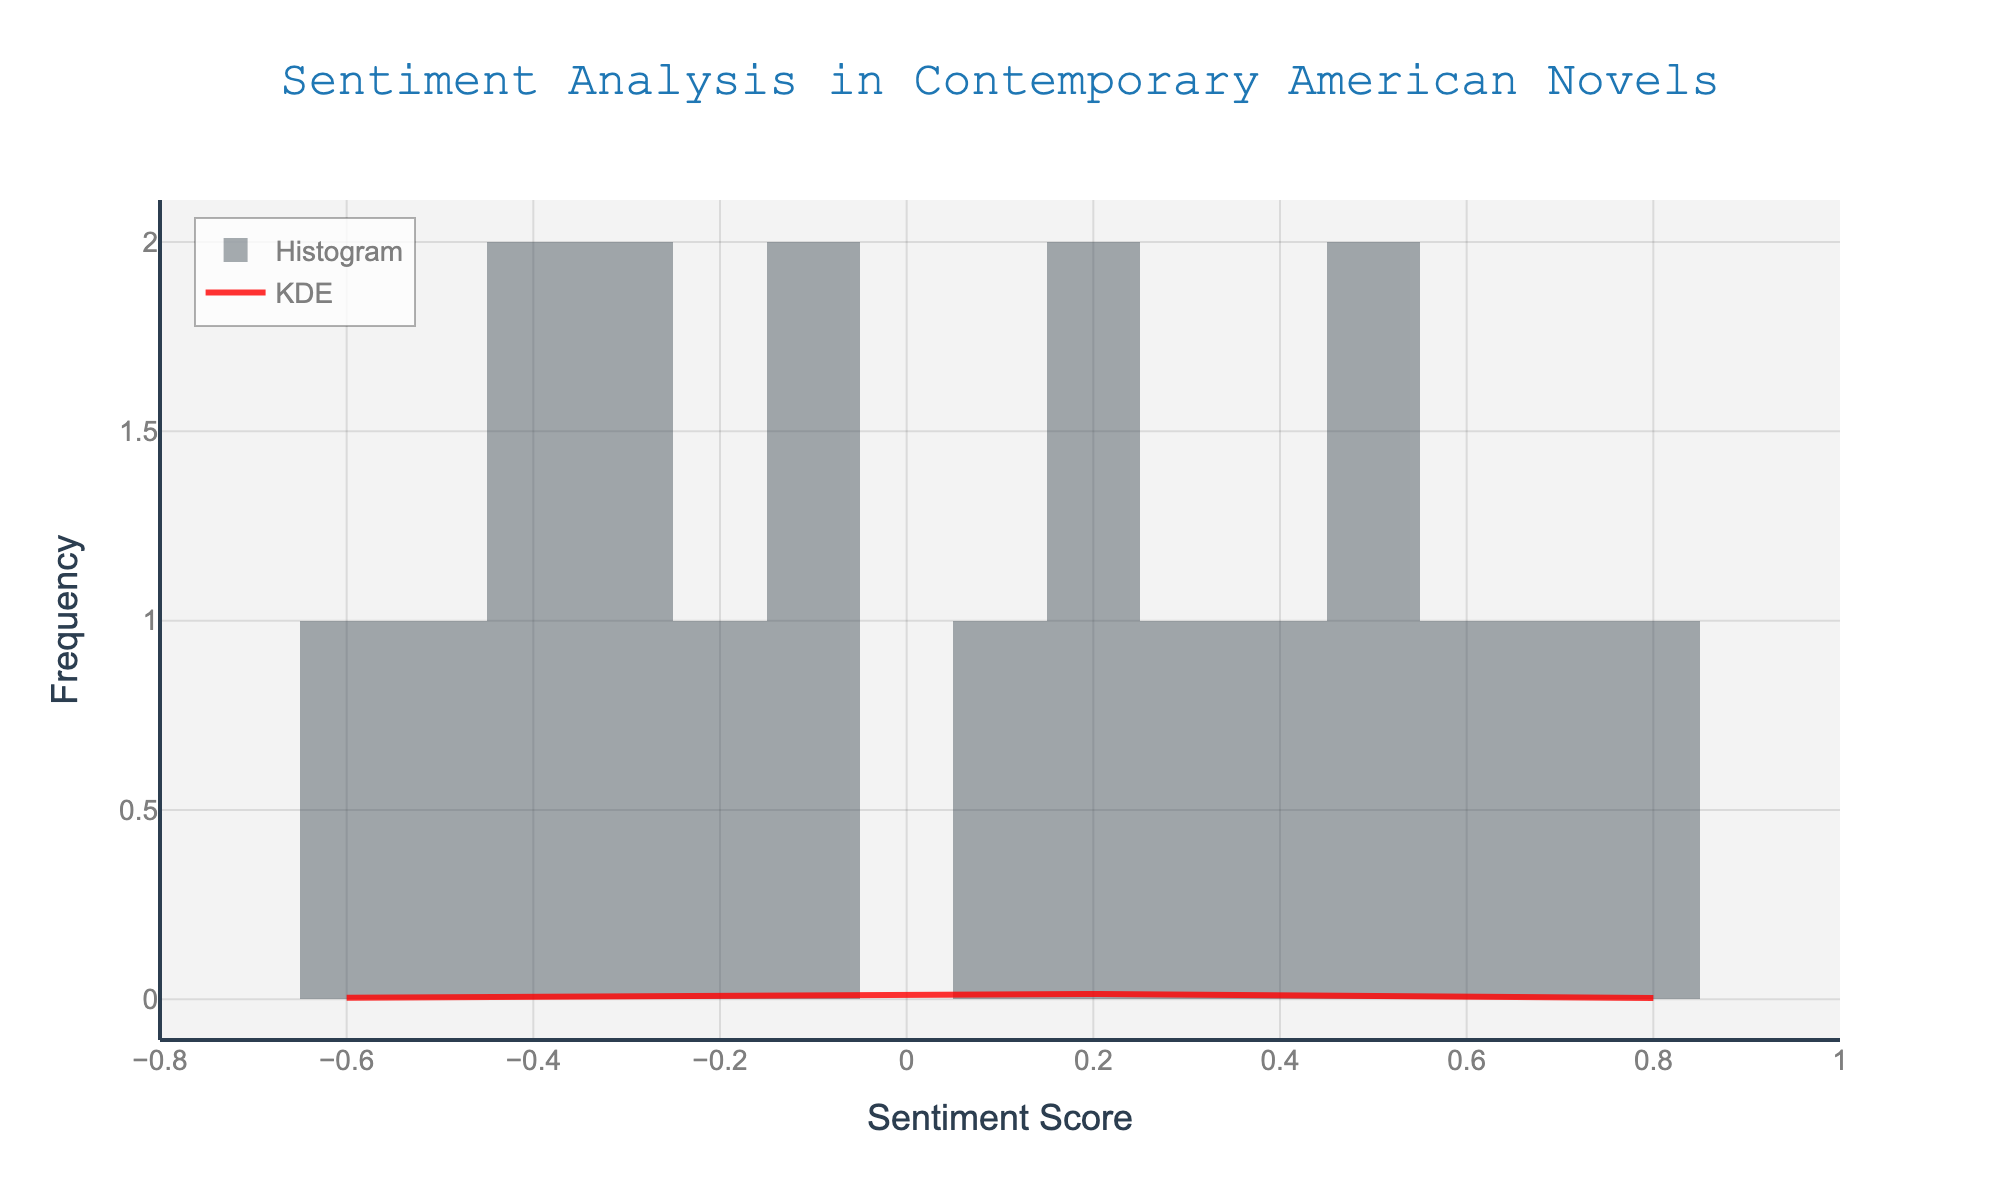What is the title of the figure? The title is prominently displayed at the top center of the figure and reads "Sentiment Analysis in Contemporary American Novels"
Answer: Sentiment Analysis in Contemporary American Novels What is the range of the x-axis? The x-axis range can be determined by observing the axis labels at the bottom of the figure, which go from approximately -0.8 to 1.
Answer: -0.8 to 1 How many histogram bins are there? The number of bins can be counted directly by observing the columns in the histogram. There are 15 bins.
Answer: 15 What color is the KDE line? The color of the KDE line can be identified by looking at the legend which indicates the KDE line in red, also, the KDE line itself is visually red.
Answer: Red What does a KDE line represent in this figure? The KDE line is a smoothed representation of the data's distribution, estimating the probability density function of the sentiment scores.
Answer: Probability density function Which sentiment score appears most frequently in the novels? By observing the height of the histogram bars, the bin with the highest frequency is around the sentiment score of 0.1.
Answer: 0.1 How does the sentiment distribution skew? Looking at the histogram and the KDE line, the figure shows that more values cluster around the negative/neutral range with a longer tail extending into the positive sentiment scores, indicating a slight right skew.
Answer: Slight right skew What is the typical emotional tone pattern in contemporary American novels according to this figure? The histogram and KDE line both indicate a central peak around neutral to slightly positive sentiment scores, with fewer extremely negative or positive scores.
Answer: Neutral to slightly positive Compare the frequency of novels with negative sentiment scores to those with positive sentiment scores. By observing the histogram, more bars are higher in the positive range (>0) compared to the negative range (<0), indicating more novels have positive sentiment scores.
Answer: More positive sentiment scores Which bin width for the histogram seemed to be used based on the visual? Given that the x-axis ranges from -0.8 to 1 and there are 15 bins, the bin width can be approximated by (1 - (-0.8)) / 15, which is about 0.12.
Answer: Approximately 0.12 Where does the highest density lie according to the KDE? The highest point on the KDE line indicates the highest density, which occurs around the sentiment score of 0.1 to 0.2.
Answer: Around 0.1 to 0.2 